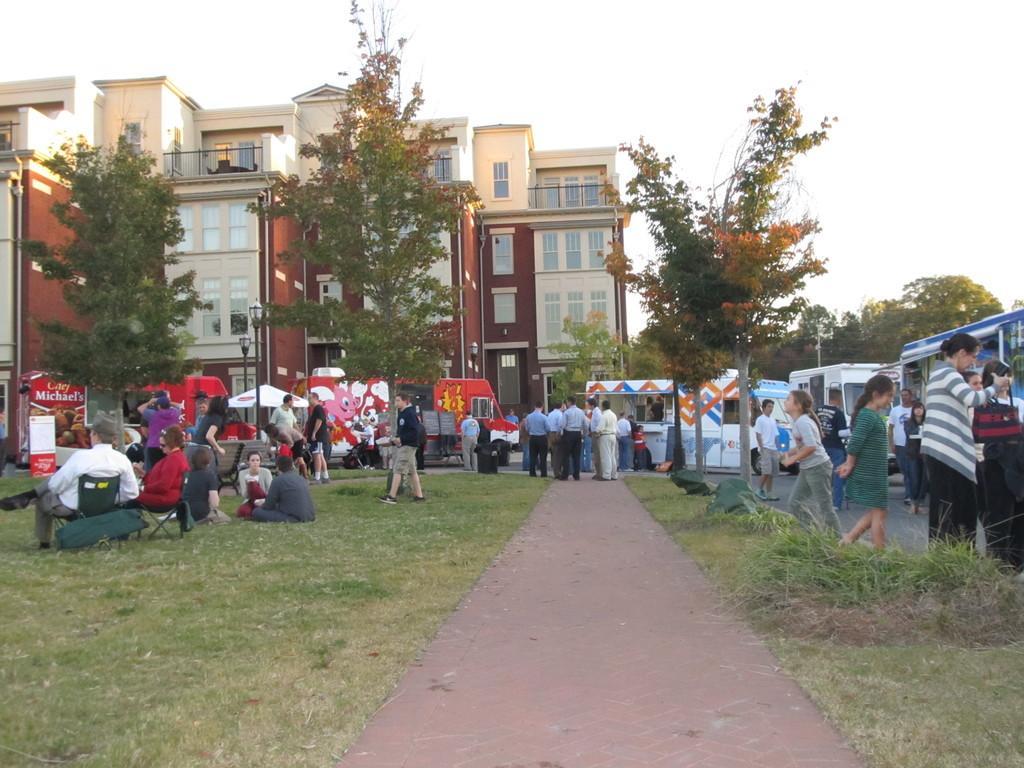Describe this image in one or two sentences. In this picture I can see group of people standing, group of people sitting, there are chairs, a building, trees, grass, there are vehicles, umbrella with a pole, and in the background there is sky. 